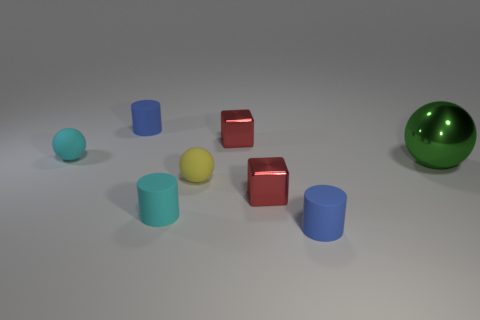Are there any large green shiny things that are behind the blue thing to the left of the small block that is behind the big green thing?
Provide a short and direct response. No. How big is the ball that is to the right of the red metal thing that is behind the yellow matte ball?
Keep it short and to the point. Large. How many objects are either red cubes in front of the big green metallic ball or cyan rubber objects?
Your answer should be very brief. 3. Is there a cyan thing of the same size as the green sphere?
Provide a succinct answer. No. Are there any metallic balls in front of the small blue cylinder behind the green object?
Your answer should be very brief. Yes. How many balls are gray rubber objects or blue rubber things?
Make the answer very short. 0. Are there any other small things that have the same shape as the yellow object?
Your response must be concise. Yes. What is the shape of the big green thing?
Provide a succinct answer. Sphere. How many things are small red metal things or tiny red cylinders?
Provide a succinct answer. 2. There is a red metal object in front of the big sphere; is it the same size as the rubber ball that is behind the green ball?
Your response must be concise. Yes. 